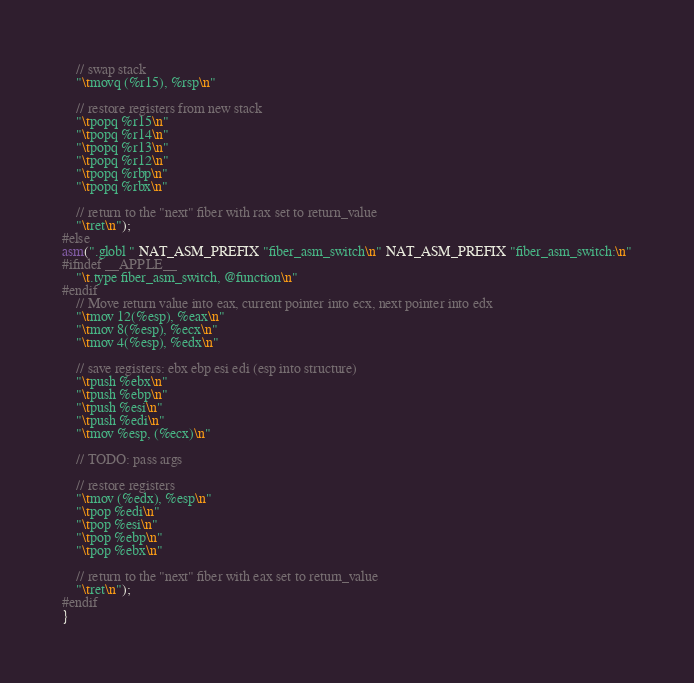<code> <loc_0><loc_0><loc_500><loc_500><_C++_>
    // swap stack
    "\tmovq (%r15), %rsp\n"

    // restore registers from new stack
    "\tpopq %r15\n"
    "\tpopq %r14\n"
    "\tpopq %r13\n"
    "\tpopq %r12\n"
    "\tpopq %rbp\n"
    "\tpopq %rbx\n"

    // return to the "next" fiber with rax set to return_value
    "\tret\n");
#else
asm(".globl " NAT_ASM_PREFIX "fiber_asm_switch\n" NAT_ASM_PREFIX "fiber_asm_switch:\n"
#ifndef __APPLE__
    "\t.type fiber_asm_switch, @function\n"
#endif
    // Move return value into eax, current pointer into ecx, next pointer into edx
    "\tmov 12(%esp), %eax\n"
    "\tmov 8(%esp), %ecx\n"
    "\tmov 4(%esp), %edx\n"

    // save registers: ebx ebp esi edi (esp into structure)
    "\tpush %ebx\n"
    "\tpush %ebp\n"
    "\tpush %esi\n"
    "\tpush %edi\n"
    "\tmov %esp, (%ecx)\n"

    // TODO: pass args

    // restore registers
    "\tmov (%edx), %esp\n"
    "\tpop %edi\n"
    "\tpop %esi\n"
    "\tpop %ebp\n"
    "\tpop %ebx\n"

    // return to the "next" fiber with eax set to return_value
    "\tret\n");
#endif
}
</code> 